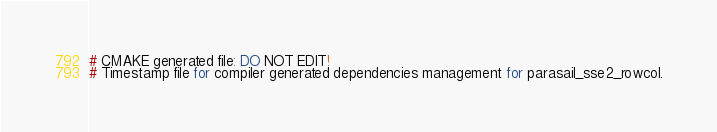<code> <loc_0><loc_0><loc_500><loc_500><_TypeScript_># CMAKE generated file: DO NOT EDIT!
# Timestamp file for compiler generated dependencies management for parasail_sse2_rowcol.
</code> 